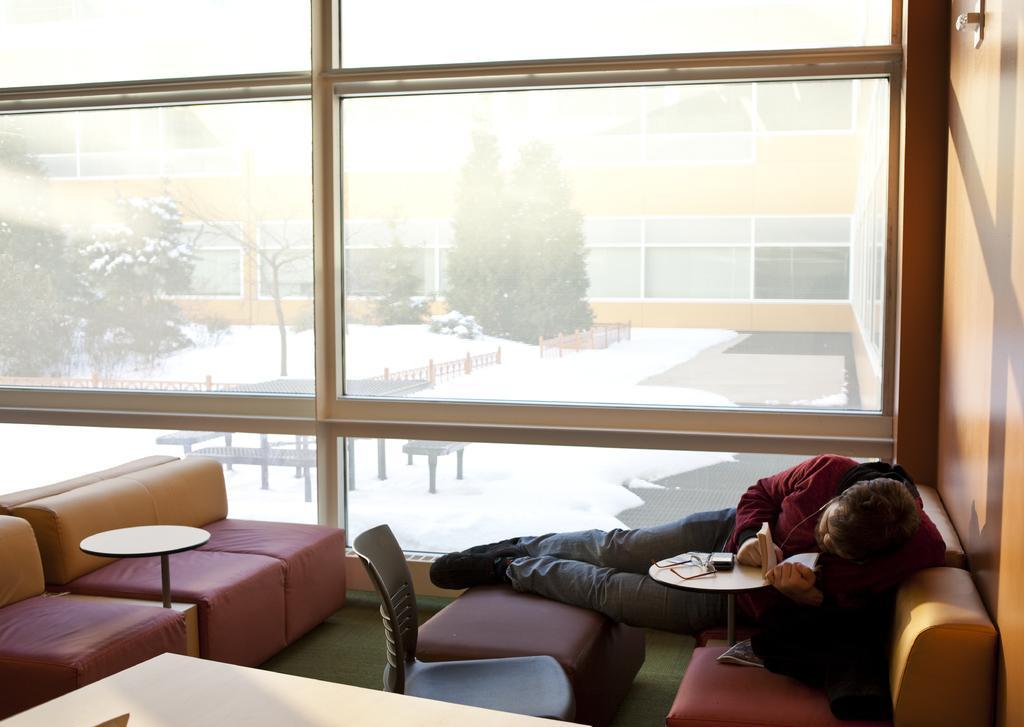In one or two sentences, can you explain what this image depicts? In this picture we can see the inside view of a room. These are the sofa and this is the chair. And there is a table. Here we can see a man who is laying on the sofa. And this is the glass. On the background we can see some trees. And this is snow. And there is a building. 